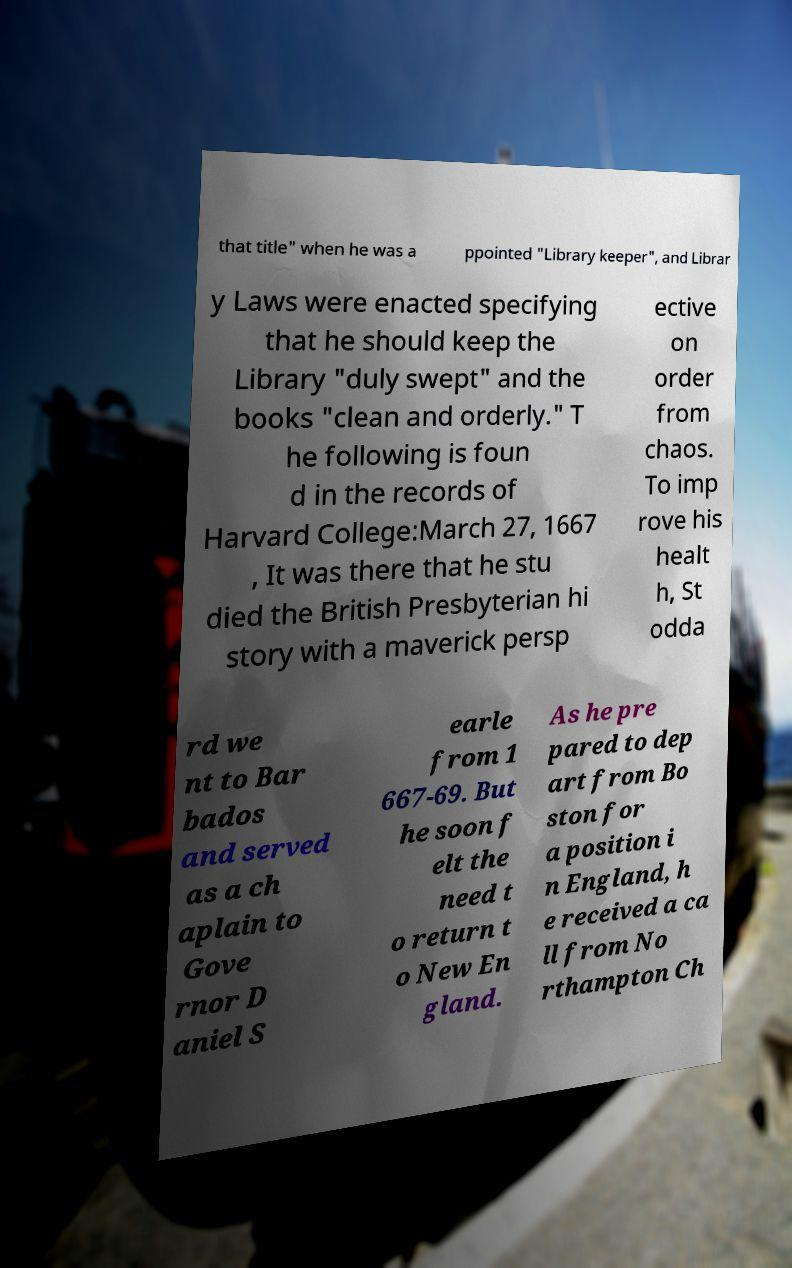Please identify and transcribe the text found in this image. that title" when he was a ppointed "Library keeper", and Librar y Laws were enacted specifying that he should keep the Library "duly swept" and the books "clean and orderly." T he following is foun d in the records of Harvard College:March 27, 1667 , It was there that he stu died the British Presbyterian hi story with a maverick persp ective on order from chaos. To imp rove his healt h, St odda rd we nt to Bar bados and served as a ch aplain to Gove rnor D aniel S earle from 1 667-69. But he soon f elt the need t o return t o New En gland. As he pre pared to dep art from Bo ston for a position i n England, h e received a ca ll from No rthampton Ch 